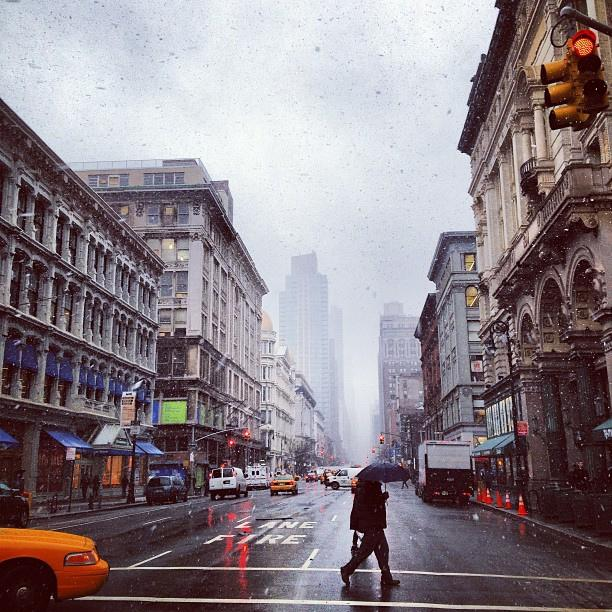What kind of vehicle can park in the middle lane?

Choices:
A) ups truck
B) delivery vehicle
C) school bus
D) fire truck fire truck 